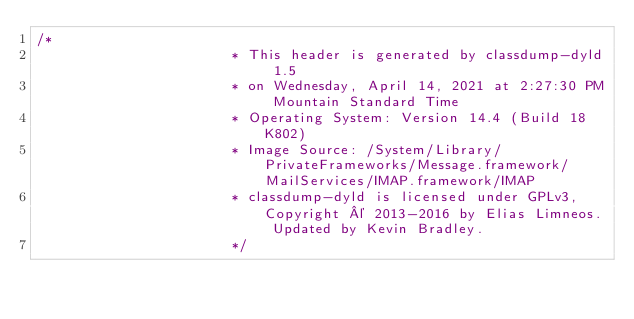<code> <loc_0><loc_0><loc_500><loc_500><_C_>/*
                       * This header is generated by classdump-dyld 1.5
                       * on Wednesday, April 14, 2021 at 2:27:30 PM Mountain Standard Time
                       * Operating System: Version 14.4 (Build 18K802)
                       * Image Source: /System/Library/PrivateFrameworks/Message.framework/MailServices/IMAP.framework/IMAP
                       * classdump-dyld is licensed under GPLv3, Copyright © 2013-2016 by Elias Limneos. Updated by Kevin Bradley.
                       */
</code> 